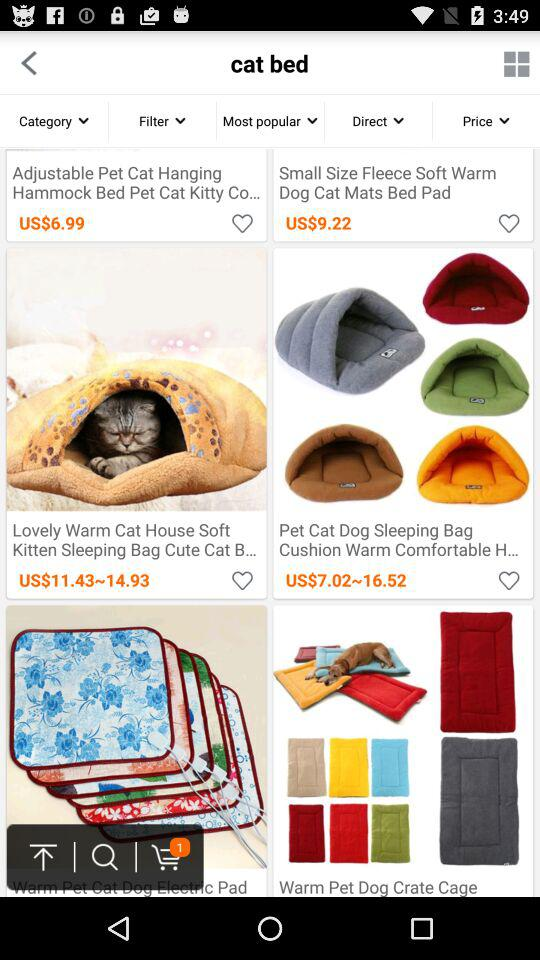How much is the price range of "Pet Cat Dog Sleeping Bag Cushion Warm Comfortable H..."? The price range is US$7.02–16.52. 